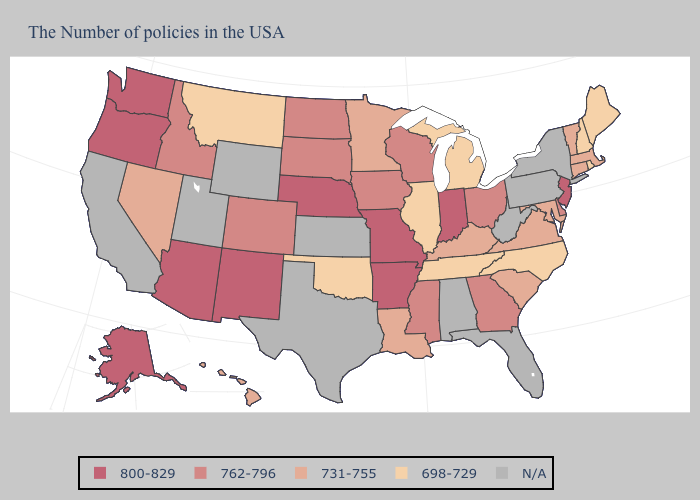What is the value of Indiana?
Write a very short answer. 800-829. Name the states that have a value in the range 698-729?
Answer briefly. Maine, Rhode Island, New Hampshire, North Carolina, Michigan, Tennessee, Illinois, Oklahoma, Montana. Does the map have missing data?
Be succinct. Yes. Name the states that have a value in the range 800-829?
Concise answer only. New Jersey, Indiana, Missouri, Arkansas, Nebraska, New Mexico, Arizona, Washington, Oregon, Alaska. Which states have the highest value in the USA?
Keep it brief. New Jersey, Indiana, Missouri, Arkansas, Nebraska, New Mexico, Arizona, Washington, Oregon, Alaska. Does the map have missing data?
Quick response, please. Yes. Name the states that have a value in the range 762-796?
Give a very brief answer. Delaware, Ohio, Georgia, Wisconsin, Mississippi, Iowa, South Dakota, North Dakota, Colorado, Idaho. What is the lowest value in the USA?
Short answer required. 698-729. Among the states that border Nevada , does Oregon have the highest value?
Short answer required. Yes. Is the legend a continuous bar?
Keep it brief. No. What is the highest value in the USA?
Be succinct. 800-829. Among the states that border Vermont , does Massachusetts have the highest value?
Answer briefly. Yes. Does Idaho have the lowest value in the West?
Concise answer only. No. Which states have the highest value in the USA?
Write a very short answer. New Jersey, Indiana, Missouri, Arkansas, Nebraska, New Mexico, Arizona, Washington, Oregon, Alaska. 